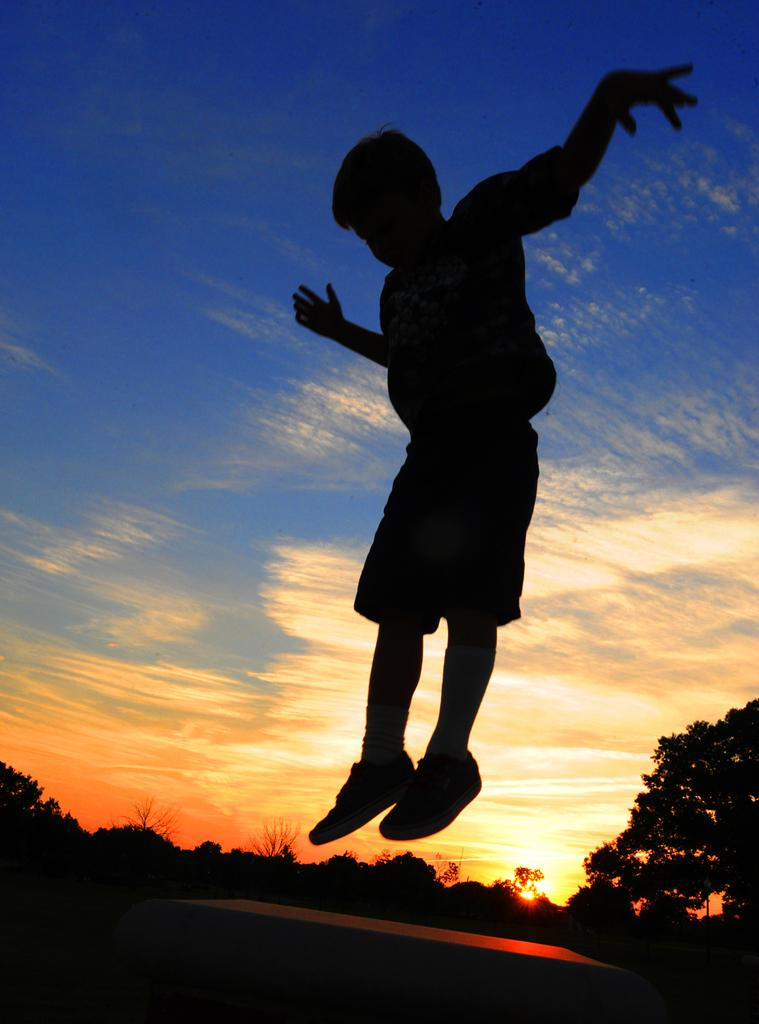Who is the main subject in the image? There is a boy in the image. What is the boy doing in the image? The boy is jumping. What can be seen at the bottom of the image? There is an object at the bottom of the image. What type of natural environment is visible in the background of the image? There are trees visible in the background of the image. What is visible at the top of the image? The sky is visible at the top of the image. Can you describe the sky in the image? The sky is visible at the top of the image, and there are clouds and the sun present. What type of kite is the boy flying in the image? There is no kite present in the image; the boy is simply jumping. What curve is the boy trying to hammer in the image? There is no hammer or curve present in the image. 